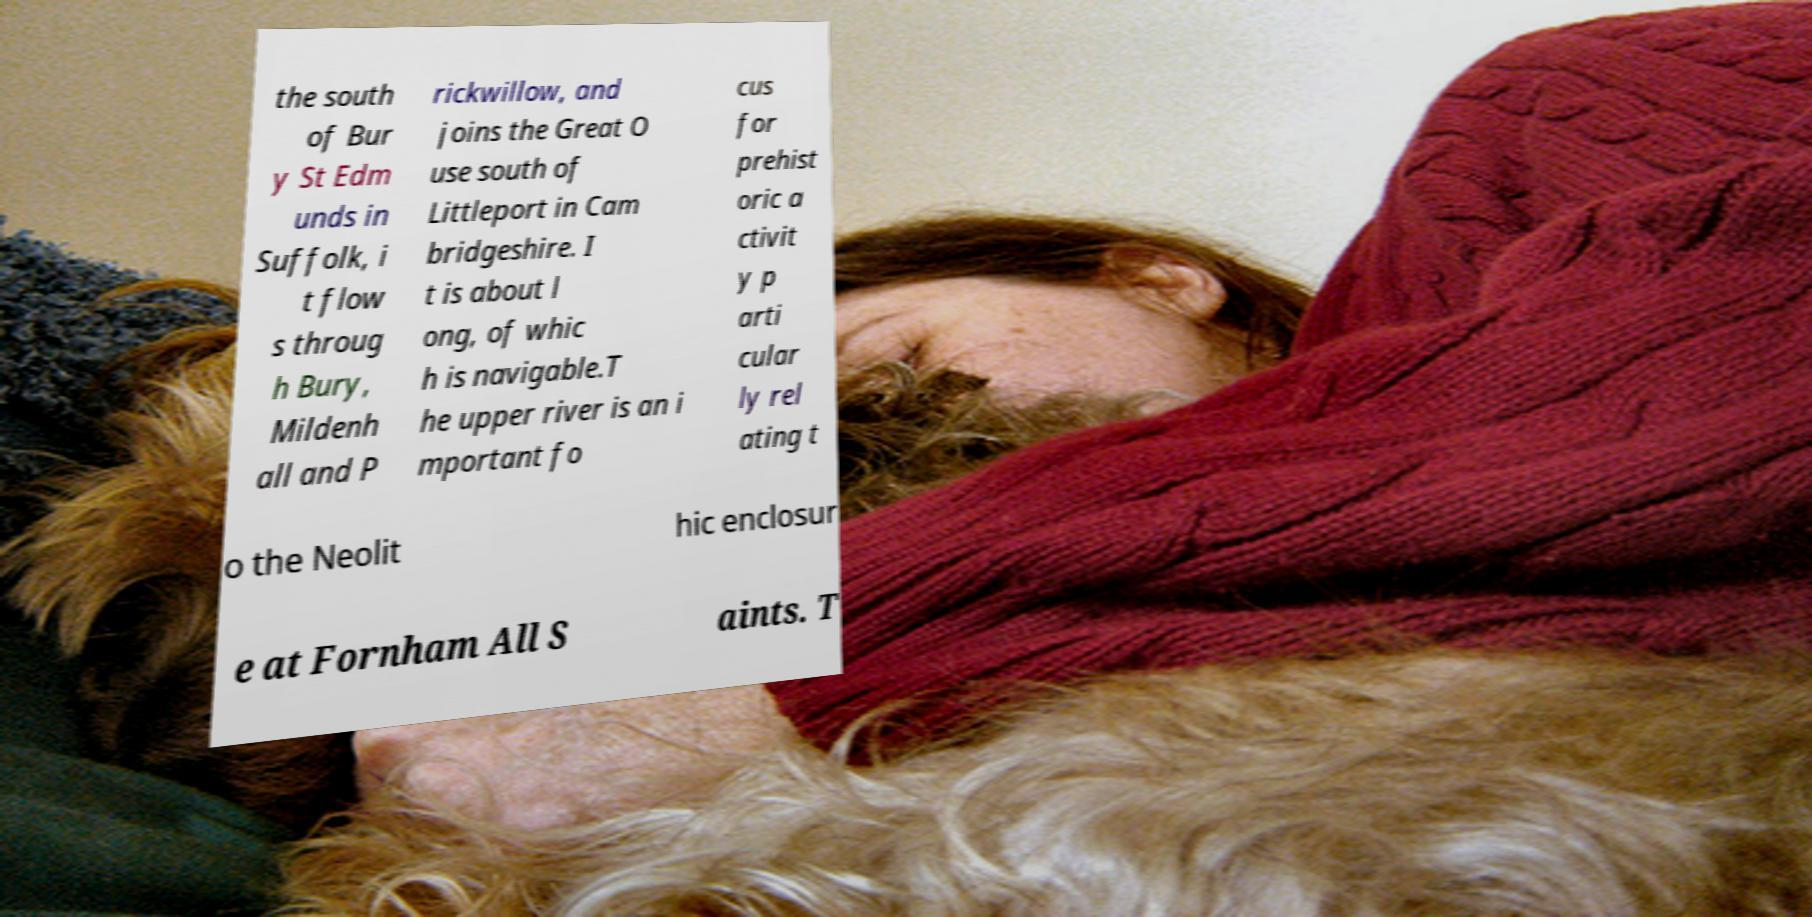For documentation purposes, I need the text within this image transcribed. Could you provide that? the south of Bur y St Edm unds in Suffolk, i t flow s throug h Bury, Mildenh all and P rickwillow, and joins the Great O use south of Littleport in Cam bridgeshire. I t is about l ong, of whic h is navigable.T he upper river is an i mportant fo cus for prehist oric a ctivit y p arti cular ly rel ating t o the Neolit hic enclosur e at Fornham All S aints. T 